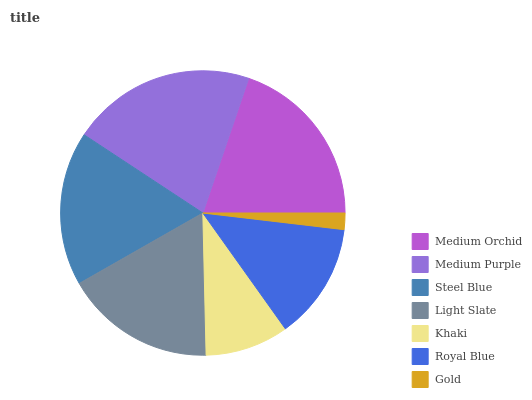Is Gold the minimum?
Answer yes or no. Yes. Is Medium Purple the maximum?
Answer yes or no. Yes. Is Steel Blue the minimum?
Answer yes or no. No. Is Steel Blue the maximum?
Answer yes or no. No. Is Medium Purple greater than Steel Blue?
Answer yes or no. Yes. Is Steel Blue less than Medium Purple?
Answer yes or no. Yes. Is Steel Blue greater than Medium Purple?
Answer yes or no. No. Is Medium Purple less than Steel Blue?
Answer yes or no. No. Is Light Slate the high median?
Answer yes or no. Yes. Is Light Slate the low median?
Answer yes or no. Yes. Is Khaki the high median?
Answer yes or no. No. Is Medium Purple the low median?
Answer yes or no. No. 